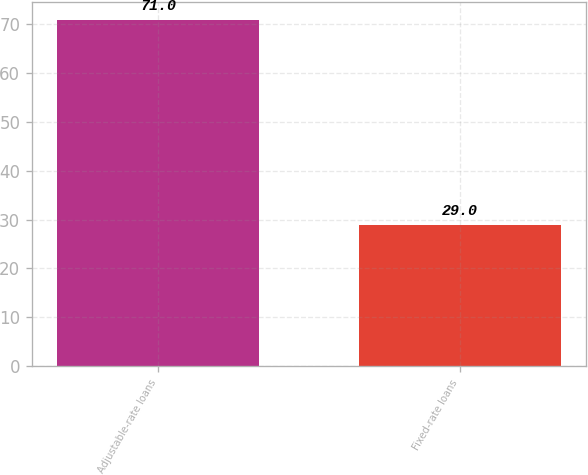<chart> <loc_0><loc_0><loc_500><loc_500><bar_chart><fcel>Adjustable-rate loans<fcel>Fixed-rate loans<nl><fcel>71<fcel>29<nl></chart> 